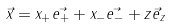<formula> <loc_0><loc_0><loc_500><loc_500>\vec { x } = x _ { + } \vec { e _ { + } } + x _ { - } \vec { e _ { - } } + z \vec { e } _ { z }</formula> 